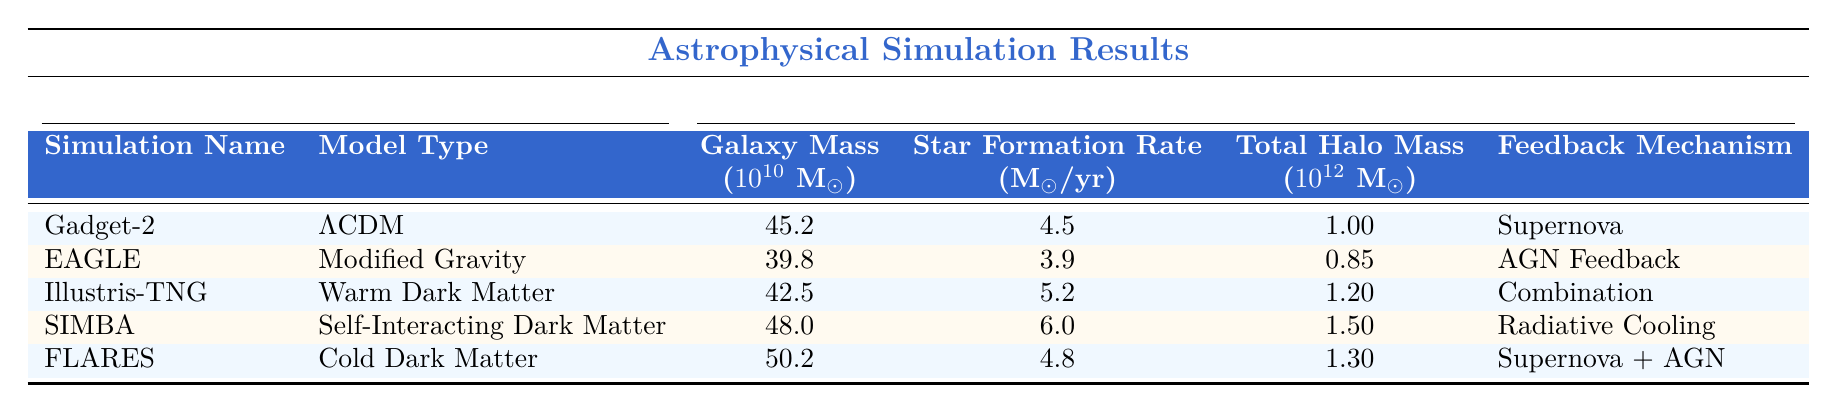What is the galaxy mass of the simulation named 'EAGLE'? In the table, under the 'Simulation Name' column, the entry for 'EAGLE' shows 'Galaxy Mass (10^10 M☉)' as 39.8.
Answer: 39.8 Which simulation has the highest star formation rate? By examining the 'Star Formation Rate (M☉/yr)' column, the highest value of 6.0 corresponds to the 'SIMBA' simulation.
Answer: SIMBA Is the feedback mechanism used in the 'Illustris-TNG' simulation a supernova? In the table, 'Illustris-TNG' is listed with a feedback mechanism of 'Combination', not 'Supernova', so this statement is false.
Answer: No What is the total halo mass of the 'Gadget-2' simulation? Looking under the 'Total Halo Mass (10^12 M☉)' column for 'Gadget-2', the value provided is 1.00.
Answer: 1.00 Calculate the average galaxy mass across all simulations. The galaxy masses are 45.2, 39.8, 42.5, 48.0, and 50.2. Their sum is 225.7, and dividing by 5 gives an average of 45.14.
Answer: 45.14 Which simulation's star formation rate is closest to 5.0 M☉/yr? The simulated star formation rates are: 4.5 (Gadget-2), 3.9 (EAGLE), 5.2 (Illustris-TNG), 6.0 (SIMBA), and 4.8 (FLARES). The nearest to 5.0 is 4.8 from 'FLARES'.
Answer: FLARES What is the total halo mass difference between 'SIMBA' and 'EAGLE'? The total halo mass for SIMBA is 1.50 and for EAGLE is 0.85. The difference is 1.50 - 0.85 = 0.65.
Answer: 0.65 In terms of star formation rates, do all simulations exceed 4.0 M☉/yr? Checking the values, the star formation rates for all simulations are 4.5, 3.9, 5.2, 6.0, and 4.8. Since 3.9 is less than 4.0, the answer is no.
Answer: No How does the galaxy mass of 'FLARES' compare to that of 'SIMBA'? The galaxy mass of FLARES is 50.2 and that of SIMBA is 48.0. Comparing these shows that FLARES has a greater galaxy mass than SIMBA.
Answer: FLARES has a greater mass What is the galaxy mass range among the simulations? The lowest galaxy mass is from EAGLE at 39.8 and the highest is from FLARES at 50.2. The range is 50.2 - 39.8 = 10.4.
Answer: 10.4 